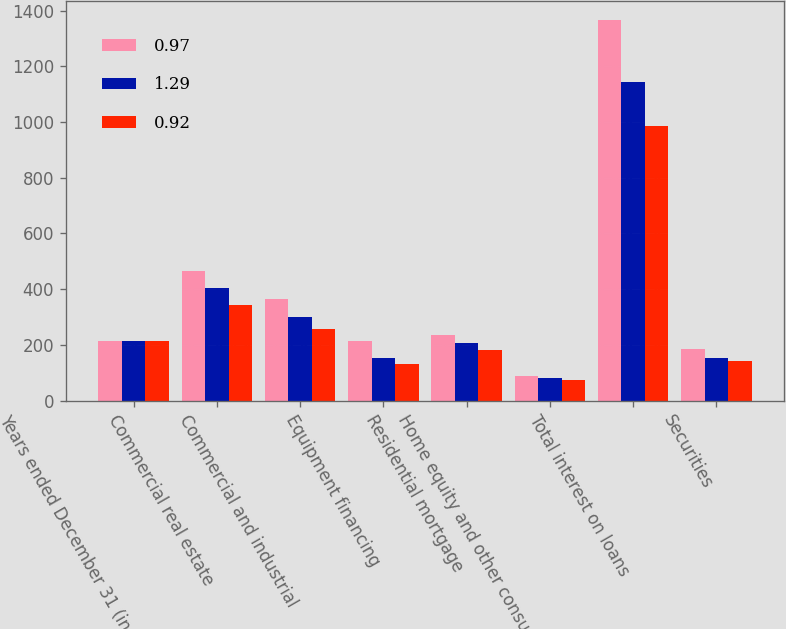Convert chart. <chart><loc_0><loc_0><loc_500><loc_500><stacked_bar_chart><ecel><fcel>Years ended December 31 (in<fcel>Commercial real estate<fcel>Commercial and industrial<fcel>Equipment financing<fcel>Residential mortgage<fcel>Home equity and other consumer<fcel>Total interest on loans<fcel>Securities<nl><fcel>0.97<fcel>212.3<fcel>463.4<fcel>365.7<fcel>212.3<fcel>236.2<fcel>88.6<fcel>1366.2<fcel>184.2<nl><fcel>1.29<fcel>212.3<fcel>405.7<fcel>298.8<fcel>152.1<fcel>207.5<fcel>80<fcel>1144.1<fcel>153.7<nl><fcel>0.92<fcel>212.3<fcel>344.6<fcel>255<fcel>130.9<fcel>180.4<fcel>73.5<fcel>984.4<fcel>140.3<nl></chart> 